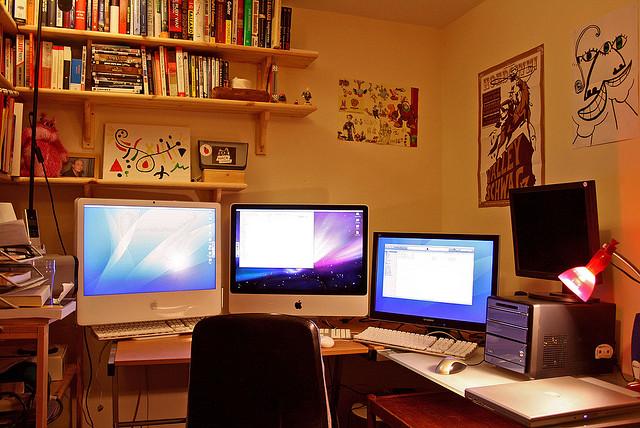Are there people in the room?
Answer briefly. No. Is there a lamp on the desk?
Write a very short answer. Yes. How many screens do you see?
Be succinct. 4. 